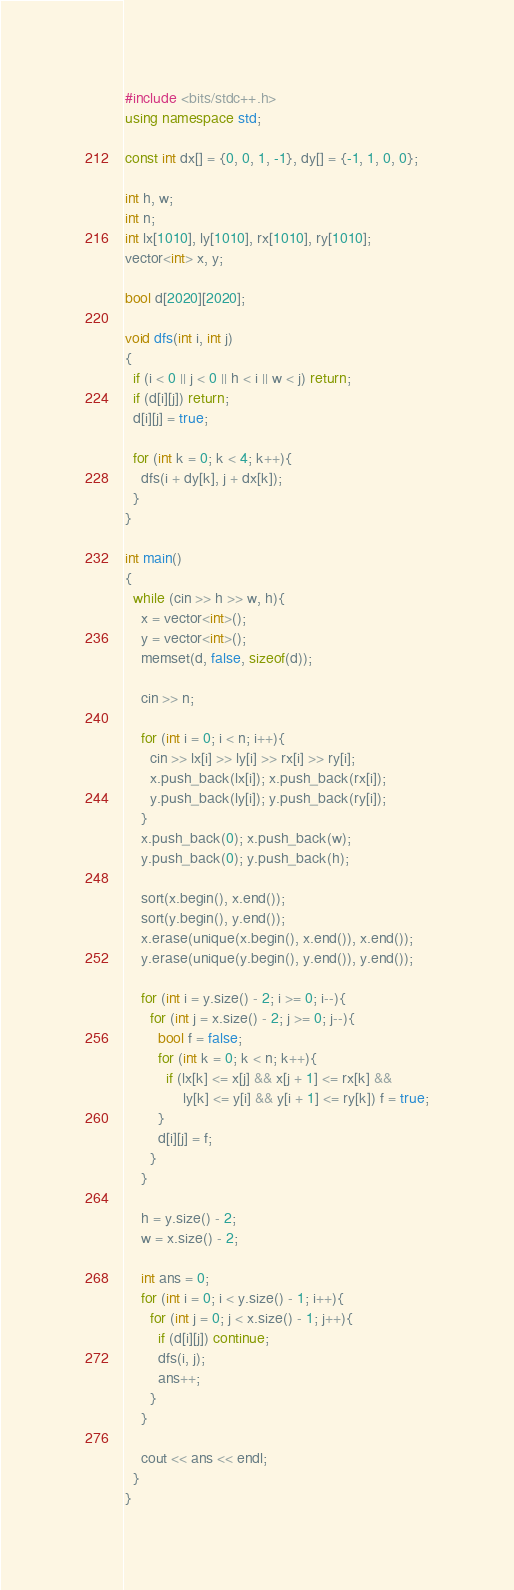Convert code to text. <code><loc_0><loc_0><loc_500><loc_500><_C++_>#include <bits/stdc++.h>
using namespace std;

const int dx[] = {0, 0, 1, -1}, dy[] = {-1, 1, 0, 0};

int h, w;
int n;
int lx[1010], ly[1010], rx[1010], ry[1010];
vector<int> x, y;

bool d[2020][2020];

void dfs(int i, int j)
{
  if (i < 0 || j < 0 || h < i || w < j) return;
  if (d[i][j]) return;
  d[i][j] = true;

  for (int k = 0; k < 4; k++){
    dfs(i + dy[k], j + dx[k]);
  }
}

int main()
{
  while (cin >> h >> w, h){
    x = vector<int>();
    y = vector<int>();
    memset(d, false, sizeof(d));
    
    cin >> n;

    for (int i = 0; i < n; i++){
      cin >> lx[i] >> ly[i] >> rx[i] >> ry[i];
      x.push_back(lx[i]); x.push_back(rx[i]);
      y.push_back(ly[i]); y.push_back(ry[i]);
    }
    x.push_back(0); x.push_back(w);
    y.push_back(0); y.push_back(h);

    sort(x.begin(), x.end());
    sort(y.begin(), y.end());
    x.erase(unique(x.begin(), x.end()), x.end());
    y.erase(unique(y.begin(), y.end()), y.end());

    for (int i = y.size() - 2; i >= 0; i--){
      for (int j = x.size() - 2; j >= 0; j--){
        bool f = false;
        for (int k = 0; k < n; k++){
          if (lx[k] <= x[j] && x[j + 1] <= rx[k] && 
              ly[k] <= y[i] && y[i + 1] <= ry[k]) f = true;
        }
        d[i][j] = f;
      }
    }

    h = y.size() - 2;
    w = x.size() - 2;

    int ans = 0;
    for (int i = 0; i < y.size() - 1; i++){
      for (int j = 0; j < x.size() - 1; j++){
        if (d[i][j]) continue;
        dfs(i, j);
        ans++;
      }
    }

    cout << ans << endl;
  }
}</code> 